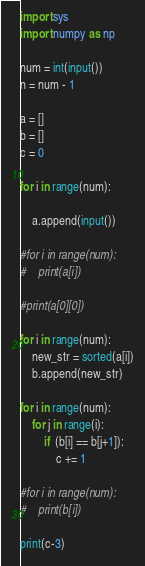<code> <loc_0><loc_0><loc_500><loc_500><_Python_>import sys
import numpy as np

num = int(input())
n = num - 1

a = []
b = []
c = 0

for i in range(num):

    a.append(input())

#for i in range(num):
#    print(a[i])

#print(a[0][0])

for i in range(num):
    new_str = sorted(a[i])
    b.append(new_str)

for i in range(num):
    for j in range(i):
        if  (b[i] == b[j+1]):
            c += 1

#for i in range(num):
#    print(b[i])

print(c-3)
</code> 